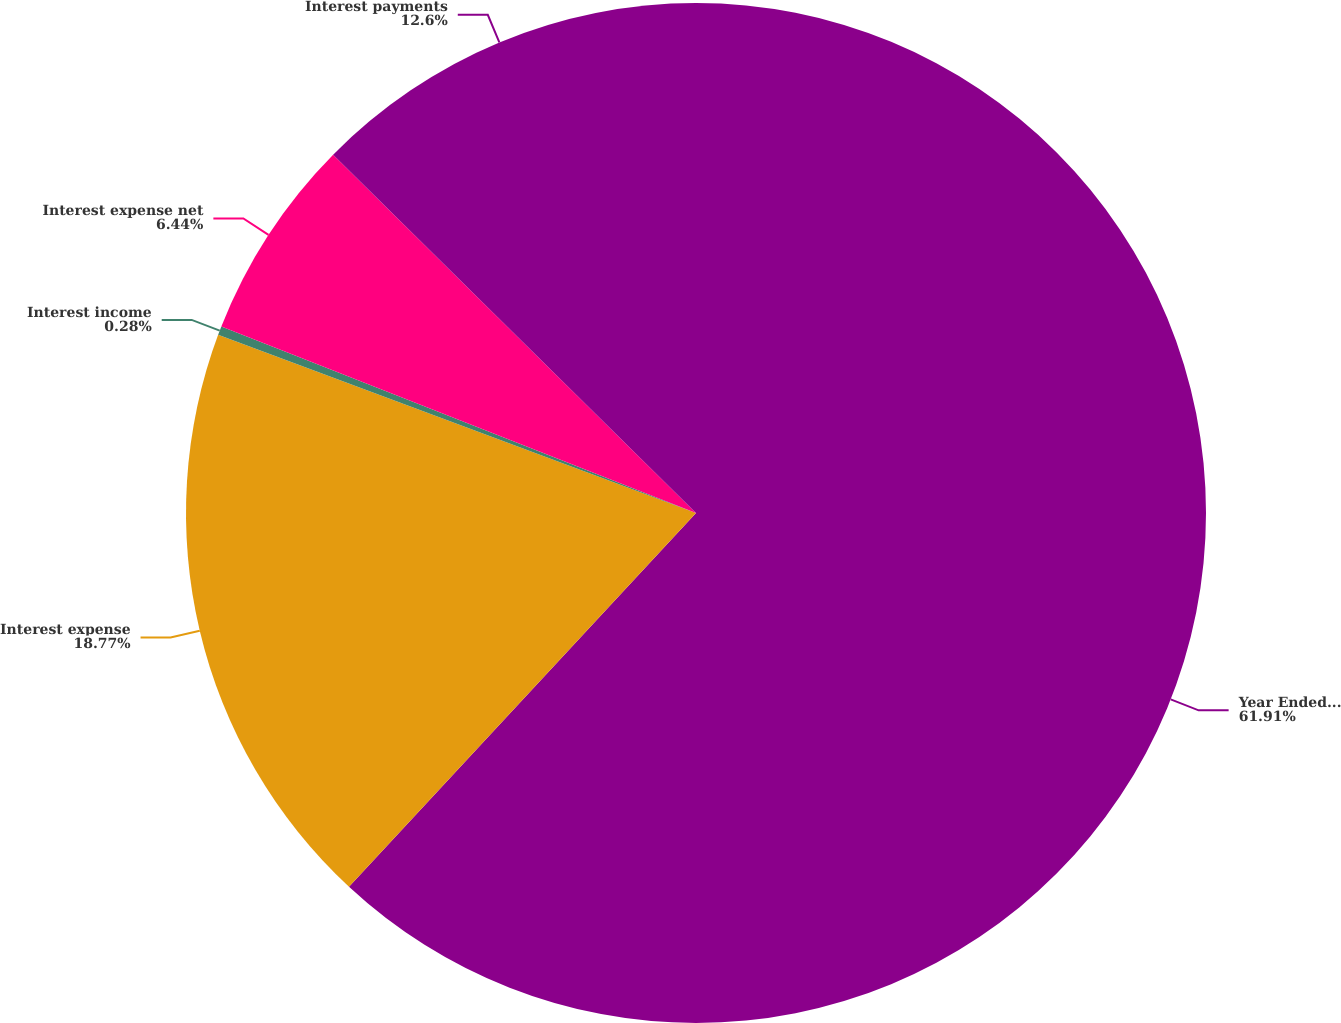Convert chart. <chart><loc_0><loc_0><loc_500><loc_500><pie_chart><fcel>Year Ended December 31<fcel>Interest expense<fcel>Interest income<fcel>Interest expense net<fcel>Interest payments<nl><fcel>61.91%<fcel>18.77%<fcel>0.28%<fcel>6.44%<fcel>12.6%<nl></chart> 